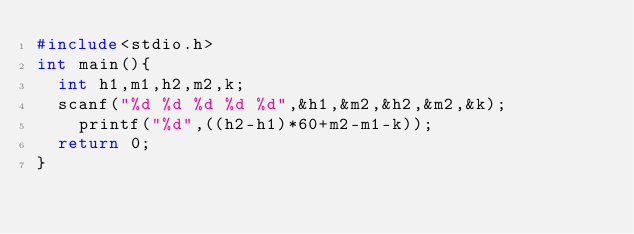<code> <loc_0><loc_0><loc_500><loc_500><_C_>#include<stdio.h>
int main(){
	int h1,m1,h2,m2,k;
	scanf("%d %d %d %d %d",&h1,&m2,&h2,&m2,&k);
		printf("%d",((h2-h1)*60+m2-m1-k));
	return 0;
}</code> 